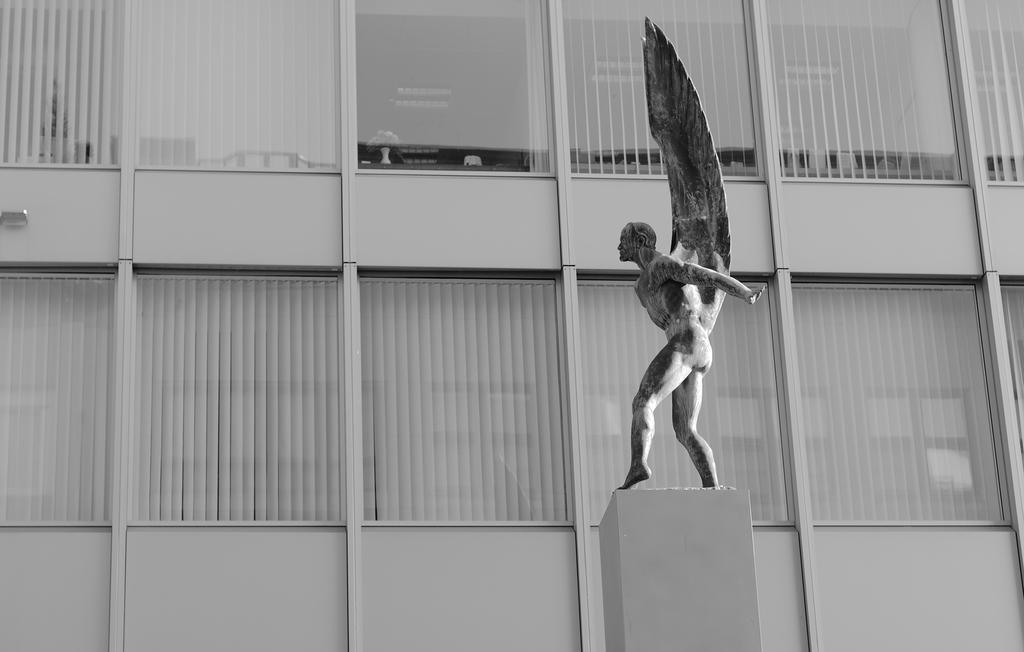In one or two sentences, can you explain what this image depicts? It is a black and white image. In this image we can see the person statue. In the background we can see the building with the glass windows and through the glass window we can see the flower vase. 